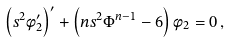<formula> <loc_0><loc_0><loc_500><loc_500>\left ( s ^ { 2 } \phi _ { 2 } ^ { \prime } \right ) ^ { \prime } + \left ( n s ^ { 2 } \Phi ^ { n - 1 } - 6 \right ) \phi _ { 2 } = 0 \, ,</formula> 